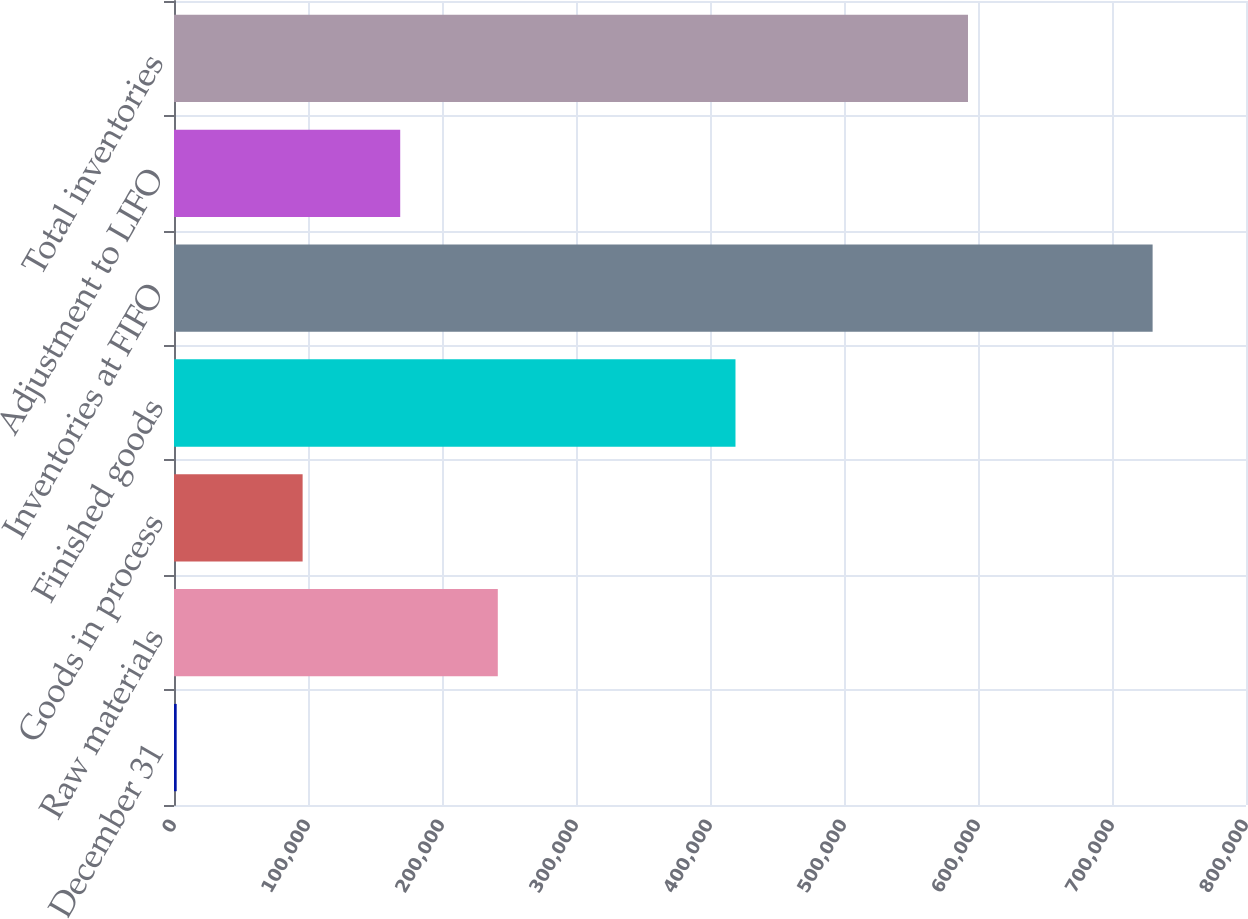Convert chart. <chart><loc_0><loc_0><loc_500><loc_500><bar_chart><fcel>December 31<fcel>Raw materials<fcel>Goods in process<fcel>Finished goods<fcel>Inventories at FIFO<fcel>Adjustment to LIFO<fcel>Total inventories<nl><fcel>2008<fcel>241647<fcel>95986<fcel>419016<fcel>730311<fcel>168816<fcel>592530<nl></chart> 